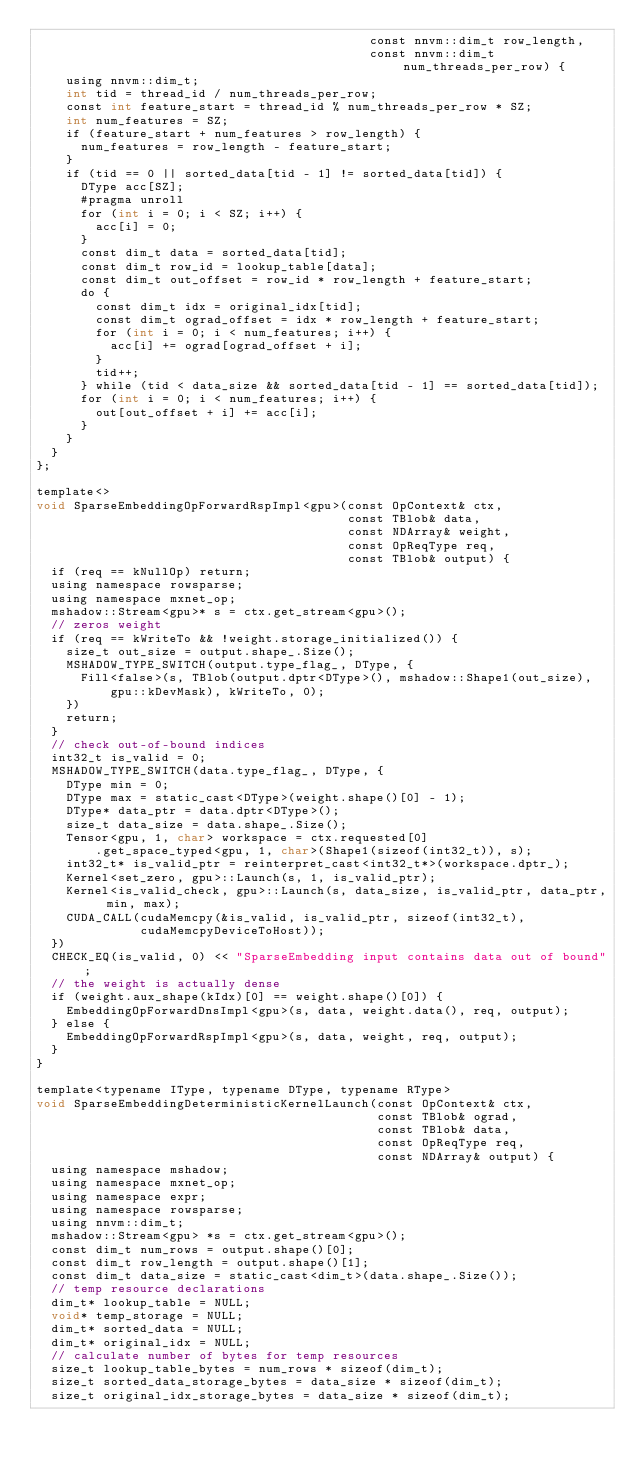<code> <loc_0><loc_0><loc_500><loc_500><_Cuda_>                                             const nnvm::dim_t row_length,
                                             const nnvm::dim_t num_threads_per_row) {
    using nnvm::dim_t;
    int tid = thread_id / num_threads_per_row;
    const int feature_start = thread_id % num_threads_per_row * SZ;
    int num_features = SZ;
    if (feature_start + num_features > row_length) {
      num_features = row_length - feature_start;
    }
    if (tid == 0 || sorted_data[tid - 1] != sorted_data[tid]) {
      DType acc[SZ];
      #pragma unroll
      for (int i = 0; i < SZ; i++) {
        acc[i] = 0;
      }
      const dim_t data = sorted_data[tid];
      const dim_t row_id = lookup_table[data];
      const dim_t out_offset = row_id * row_length + feature_start;
      do {
        const dim_t idx = original_idx[tid];
        const dim_t ograd_offset = idx * row_length + feature_start;
        for (int i = 0; i < num_features; i++) {
          acc[i] += ograd[ograd_offset + i];
        }
        tid++;
      } while (tid < data_size && sorted_data[tid - 1] == sorted_data[tid]);
      for (int i = 0; i < num_features; i++) {
        out[out_offset + i] += acc[i];
      }
    }
  }
};

template<>
void SparseEmbeddingOpForwardRspImpl<gpu>(const OpContext& ctx,
                                          const TBlob& data,
                                          const NDArray& weight,
                                          const OpReqType req,
                                          const TBlob& output) {
  if (req == kNullOp) return;
  using namespace rowsparse;
  using namespace mxnet_op;
  mshadow::Stream<gpu>* s = ctx.get_stream<gpu>();
  // zeros weight
  if (req == kWriteTo && !weight.storage_initialized()) {
    size_t out_size = output.shape_.Size();
    MSHADOW_TYPE_SWITCH(output.type_flag_, DType, {
      Fill<false>(s, TBlob(output.dptr<DType>(), mshadow::Shape1(out_size),
          gpu::kDevMask), kWriteTo, 0);
    })
    return;
  }
  // check out-of-bound indices
  int32_t is_valid = 0;
  MSHADOW_TYPE_SWITCH(data.type_flag_, DType, {
    DType min = 0;
    DType max = static_cast<DType>(weight.shape()[0] - 1);
    DType* data_ptr = data.dptr<DType>();
    size_t data_size = data.shape_.Size();
    Tensor<gpu, 1, char> workspace = ctx.requested[0]
        .get_space_typed<gpu, 1, char>(Shape1(sizeof(int32_t)), s);
    int32_t* is_valid_ptr = reinterpret_cast<int32_t*>(workspace.dptr_);
    Kernel<set_zero, gpu>::Launch(s, 1, is_valid_ptr);
    Kernel<is_valid_check, gpu>::Launch(s, data_size, is_valid_ptr, data_ptr, min, max);
    CUDA_CALL(cudaMemcpy(&is_valid, is_valid_ptr, sizeof(int32_t),
              cudaMemcpyDeviceToHost));
  })
  CHECK_EQ(is_valid, 0) << "SparseEmbedding input contains data out of bound";
  // the weight is actually dense
  if (weight.aux_shape(kIdx)[0] == weight.shape()[0]) {
    EmbeddingOpForwardDnsImpl<gpu>(s, data, weight.data(), req, output);
  } else {
    EmbeddingOpForwardRspImpl<gpu>(s, data, weight, req, output);
  }
}

template<typename IType, typename DType, typename RType>
void SparseEmbeddingDeterministicKernelLaunch(const OpContext& ctx,
                                              const TBlob& ograd,
                                              const TBlob& data,
                                              const OpReqType req,
                                              const NDArray& output) {
  using namespace mshadow;
  using namespace mxnet_op;
  using namespace expr;
  using namespace rowsparse;
  using nnvm::dim_t;
  mshadow::Stream<gpu> *s = ctx.get_stream<gpu>();
  const dim_t num_rows = output.shape()[0];
  const dim_t row_length = output.shape()[1];
  const dim_t data_size = static_cast<dim_t>(data.shape_.Size());
  // temp resource declarations
  dim_t* lookup_table = NULL;
  void* temp_storage = NULL;
  dim_t* sorted_data = NULL;
  dim_t* original_idx = NULL;
  // calculate number of bytes for temp resources
  size_t lookup_table_bytes = num_rows * sizeof(dim_t);
  size_t sorted_data_storage_bytes = data_size * sizeof(dim_t);
  size_t original_idx_storage_bytes = data_size * sizeof(dim_t);</code> 